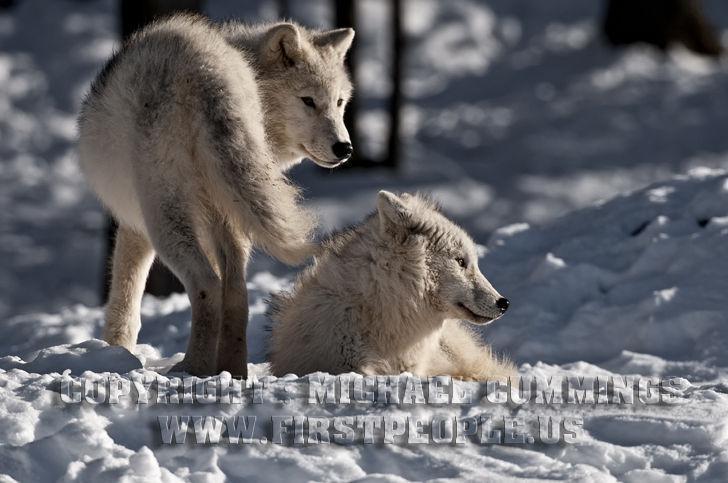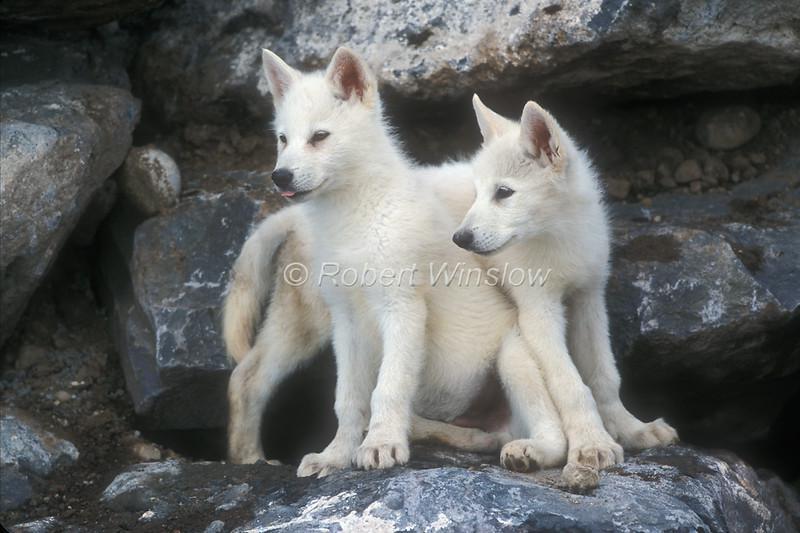The first image is the image on the left, the second image is the image on the right. For the images shown, is this caption "Two young white wolves are standing on a boulder." true? Answer yes or no. Yes. The first image is the image on the left, the second image is the image on the right. Evaluate the accuracy of this statement regarding the images: "Each image contains two wolves, and one image shows the wolves standing on a boulder with tiers of boulders behind them.". Is it true? Answer yes or no. Yes. 